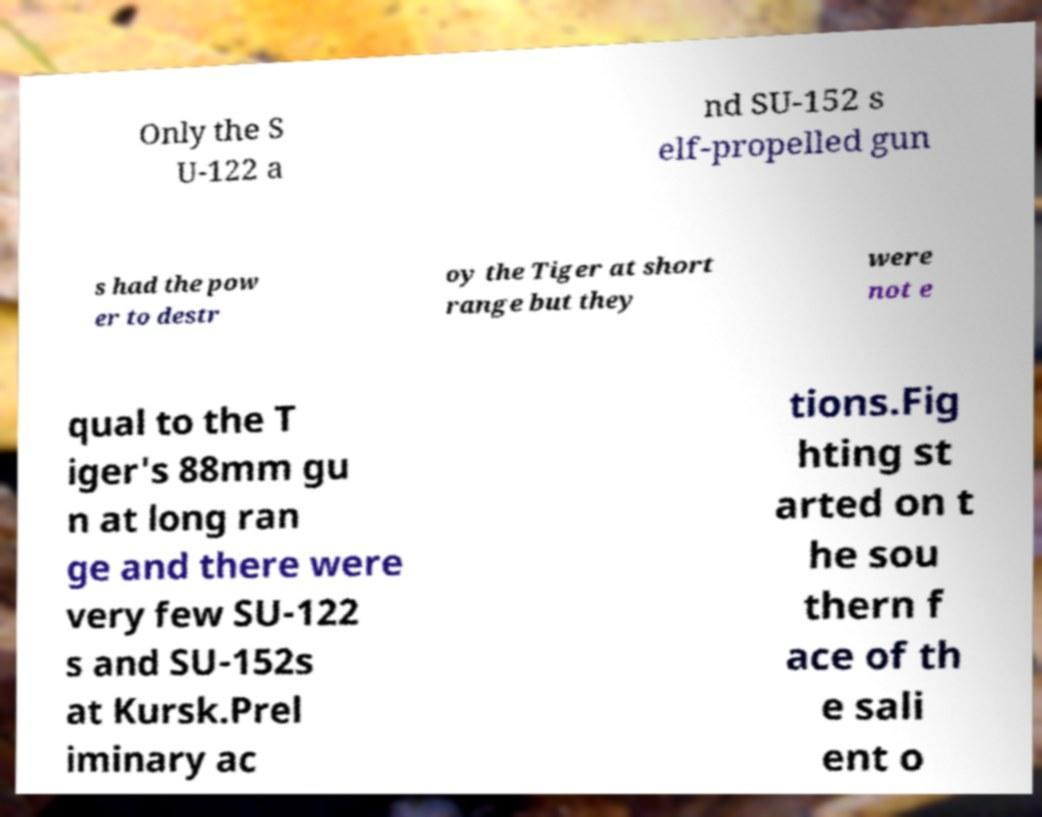Could you assist in decoding the text presented in this image and type it out clearly? Only the S U-122 a nd SU-152 s elf-propelled gun s had the pow er to destr oy the Tiger at short range but they were not e qual to the T iger's 88mm gu n at long ran ge and there were very few SU-122 s and SU-152s at Kursk.Prel iminary ac tions.Fig hting st arted on t he sou thern f ace of th e sali ent o 